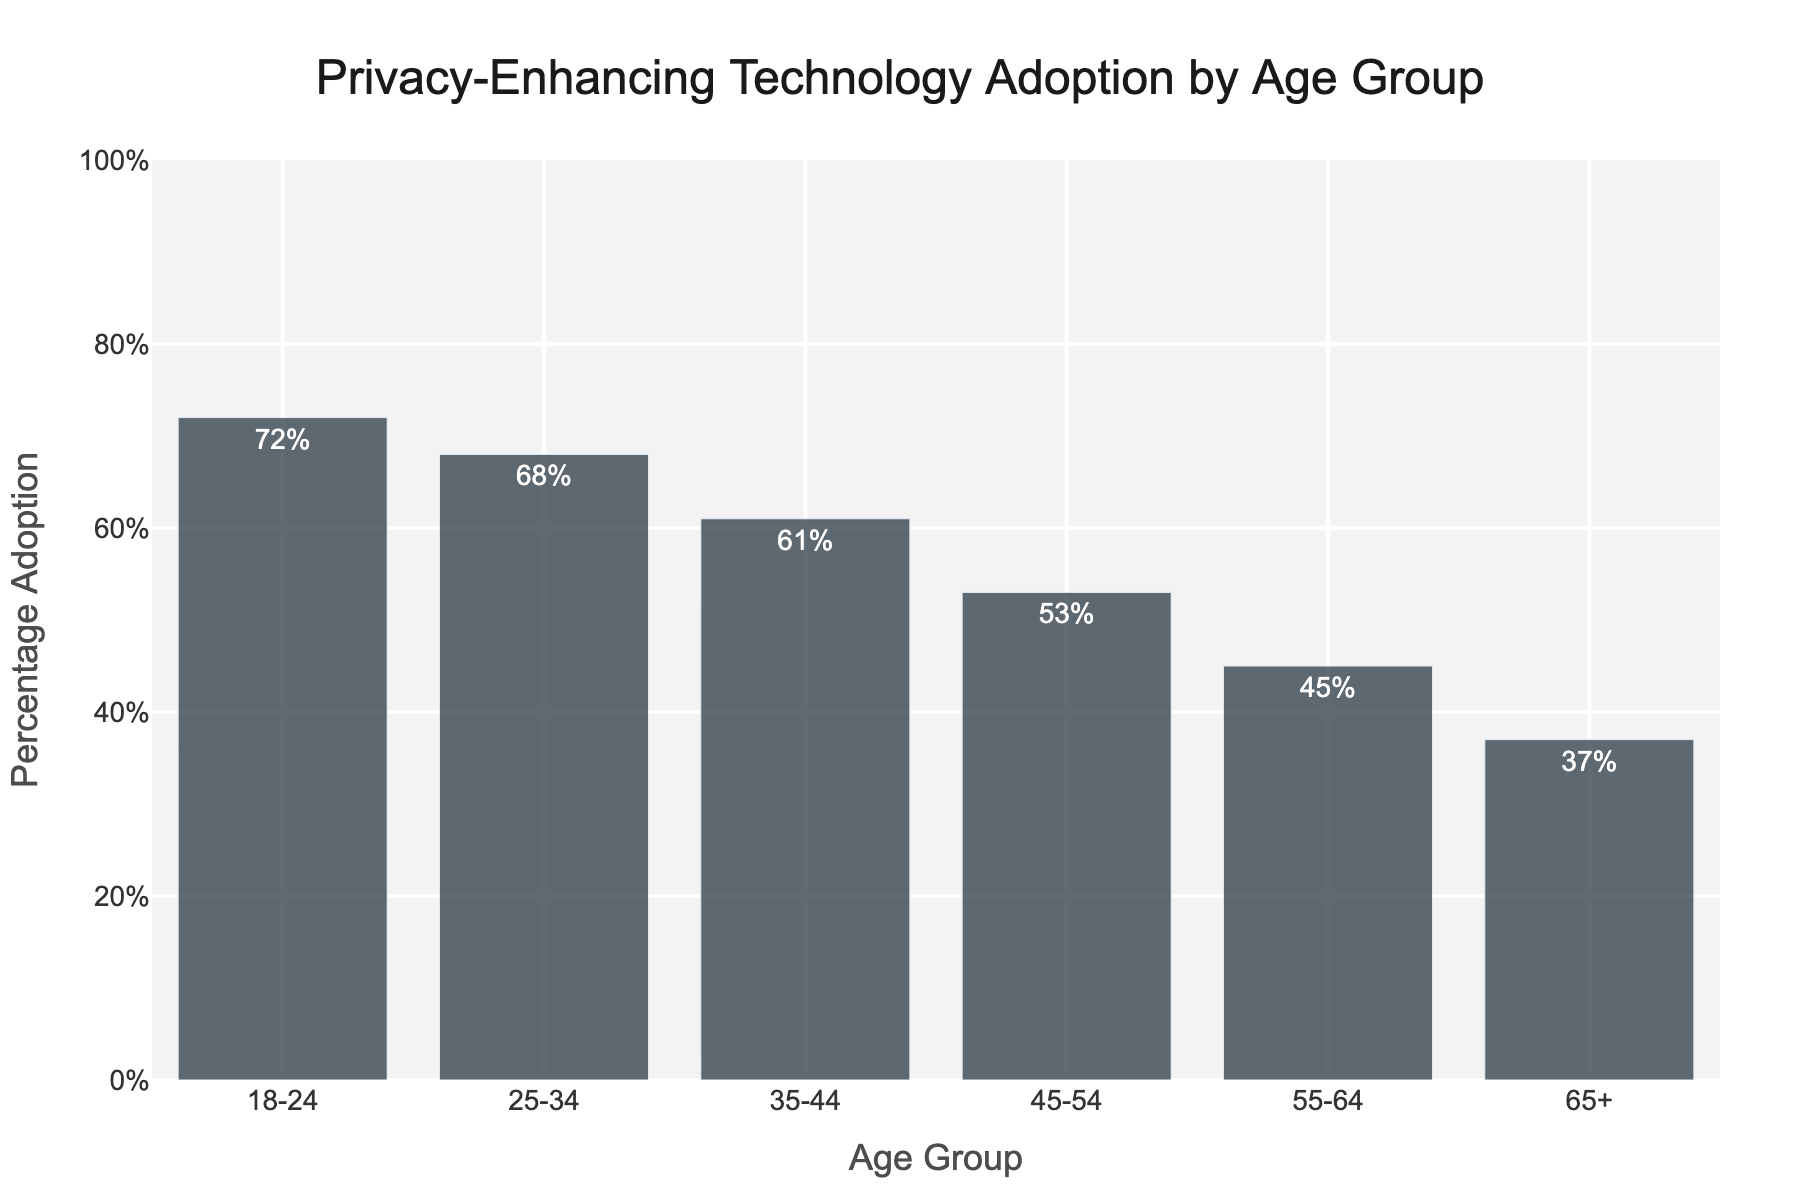What is the percentage adoption of privacy-enhancing technology for the age group 18-24? Look at the bar labeled '18-24'. The height of the bar corresponds to the percentage adoption for this age group, which is specifically labeled as '72%' on the bar itself.
Answer: 72% Which age group has the highest adoption rate of privacy-enhancing technology? Compare the heights of all the bars in the figure. The bar for the age group '18-24' is the tallest, indicating the highest adoption rate.
Answer: 18-24 What is the difference in adoption rates between the age groups 18-24 and 65+? Find the percentage adoption for 18-24 (72%) and for 65+ (37%). Subtract the adoption rate for 65+ from that of 18-24: 72% - 37% = 35%.
Answer: 35% How does the adoption rate for the 25-34 age group compare to that for the 35-44 age group? Check the height of the bars for '25-34' and '35-44'. The '25-34' group has an adoption rate of 68%, which is higher than the 61% for the '35-44' group.
Answer: 68% is higher than 61% What is the average percentage adoption across all age groups? Sum the percentage adoptions for all age groups and divide by the number of age groups: (72% + 68% + 61% + 53% + 45% + 37%) / 6 = 336% / 6 = 56%.
Answer: 56% What is the median percentage adoption for these age groups? Arrange the percentages in ascending order: 37%, 45%, 53%, 61%, 68%, 72%. The middle two values are 53% and 61%. The median is the average of these two values: (53 + 61) / 2 = 57%.
Answer: 57% Which age group has a percentage adoption of less than 50% but more than 40%? Identify the bars where the percentage adoption is between 40% and 50%. The '55-64' age group has an adoption rate of 45%, which is within this range.
Answer: 55-64 How many age groups have a percentage adoption rate greater than 50%? Count the bars with percentage adoptions higher than 50%. The groups are '18-24', '25-34', '35-44', '45-54', which is a total of four groups.
Answer: 4 